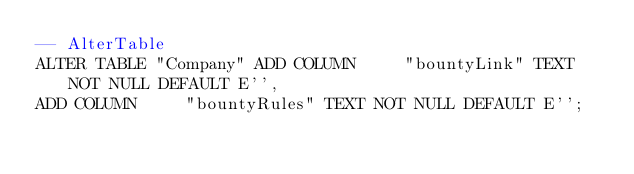Convert code to text. <code><loc_0><loc_0><loc_500><loc_500><_SQL_>-- AlterTable
ALTER TABLE "Company" ADD COLUMN     "bountyLink" TEXT NOT NULL DEFAULT E'',
ADD COLUMN     "bountyRules" TEXT NOT NULL DEFAULT E'';
</code> 